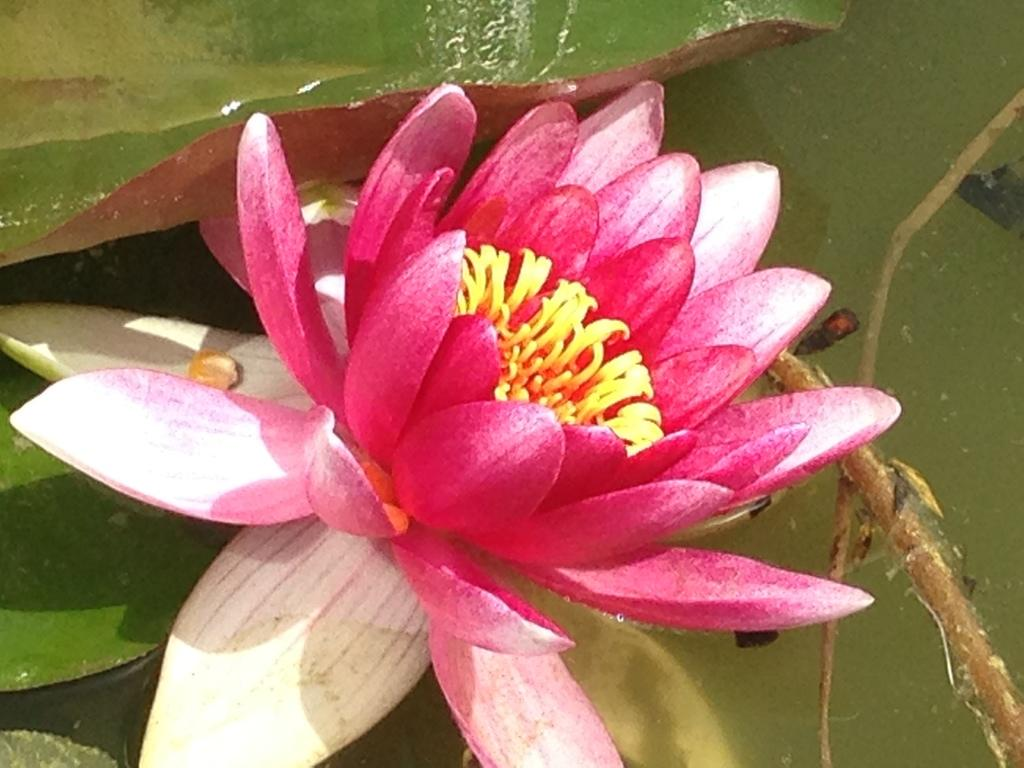What is the main subject of the image? There is a flower in the image. Can you describe the colors of the flower? The flower has pink, white, and yellow colors. What else is visible in the image besides the flower? There are green leaves in the image. Where are the leaves located in relation to the flower? The leaves are in the water. What is on the list that the flower is holding in the image? There is no list present in the image, and the flower is not holding anything. 